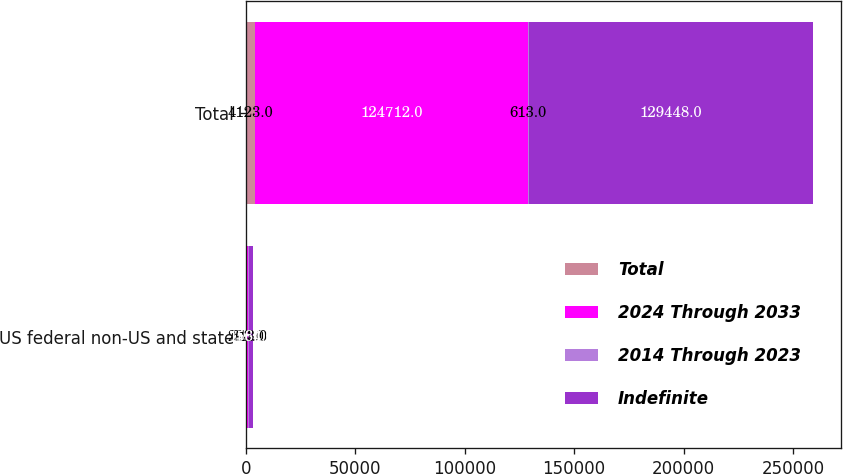Convert chart. <chart><loc_0><loc_0><loc_500><loc_500><stacked_bar_chart><ecel><fcel>US federal non-US and state<fcel>Total<nl><fcel>Total<fcel>203<fcel>4123<nl><fcel>2024 Through 2033<fcel>748<fcel>124712<nl><fcel>2014 Through 2023<fcel>613<fcel>613<nl><fcel>Indefinite<fcel>1564<fcel>129448<nl></chart> 